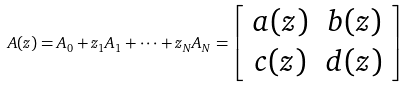Convert formula to latex. <formula><loc_0><loc_0><loc_500><loc_500>A ( z ) = A _ { 0 } + z _ { 1 } A _ { 1 } + \cdots + z _ { N } A _ { N } = \left [ \begin{array} { c c } a ( z ) & b ( z ) \\ c ( z ) & d ( z ) \end{array} \right ]</formula> 